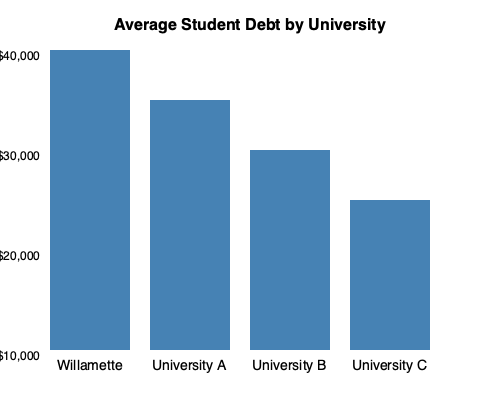Based on the bar chart comparing average student debt among Pacific Northwest universities, how much higher is the average student debt for Willamette University graduates compared to the university with the lowest average student debt shown? To answer this question, we need to follow these steps:

1. Identify Willamette University's average student debt:
   Willamette University has the tallest bar, reaching the $40,000 mark.

2. Identify the university with the lowest average student debt:
   University C has the shortest bar, reaching the $25,000 mark.

3. Calculate the difference between Willamette and the lowest:
   $40,000 - $25,000 = $15,000

Therefore, the average student debt for Willamette University graduates is $15,000 higher than the university with the lowest average student debt shown in the chart.
Answer: $15,000 